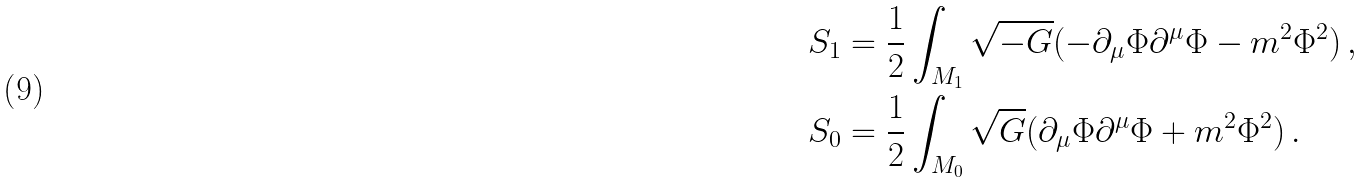<formula> <loc_0><loc_0><loc_500><loc_500>S _ { 1 } & = \frac { 1 } { 2 } \int _ { M _ { 1 } } \sqrt { - G } ( - \partial _ { \mu } \Phi \partial ^ { \mu } \Phi - m ^ { 2 } \Phi ^ { 2 } ) \, , \\ S _ { 0 } & = \frac { 1 } { 2 } \int _ { M _ { 0 } } \sqrt { G } ( \partial _ { \mu } \Phi \partial ^ { \mu } \Phi + m ^ { 2 } \Phi ^ { 2 } ) \, .</formula> 